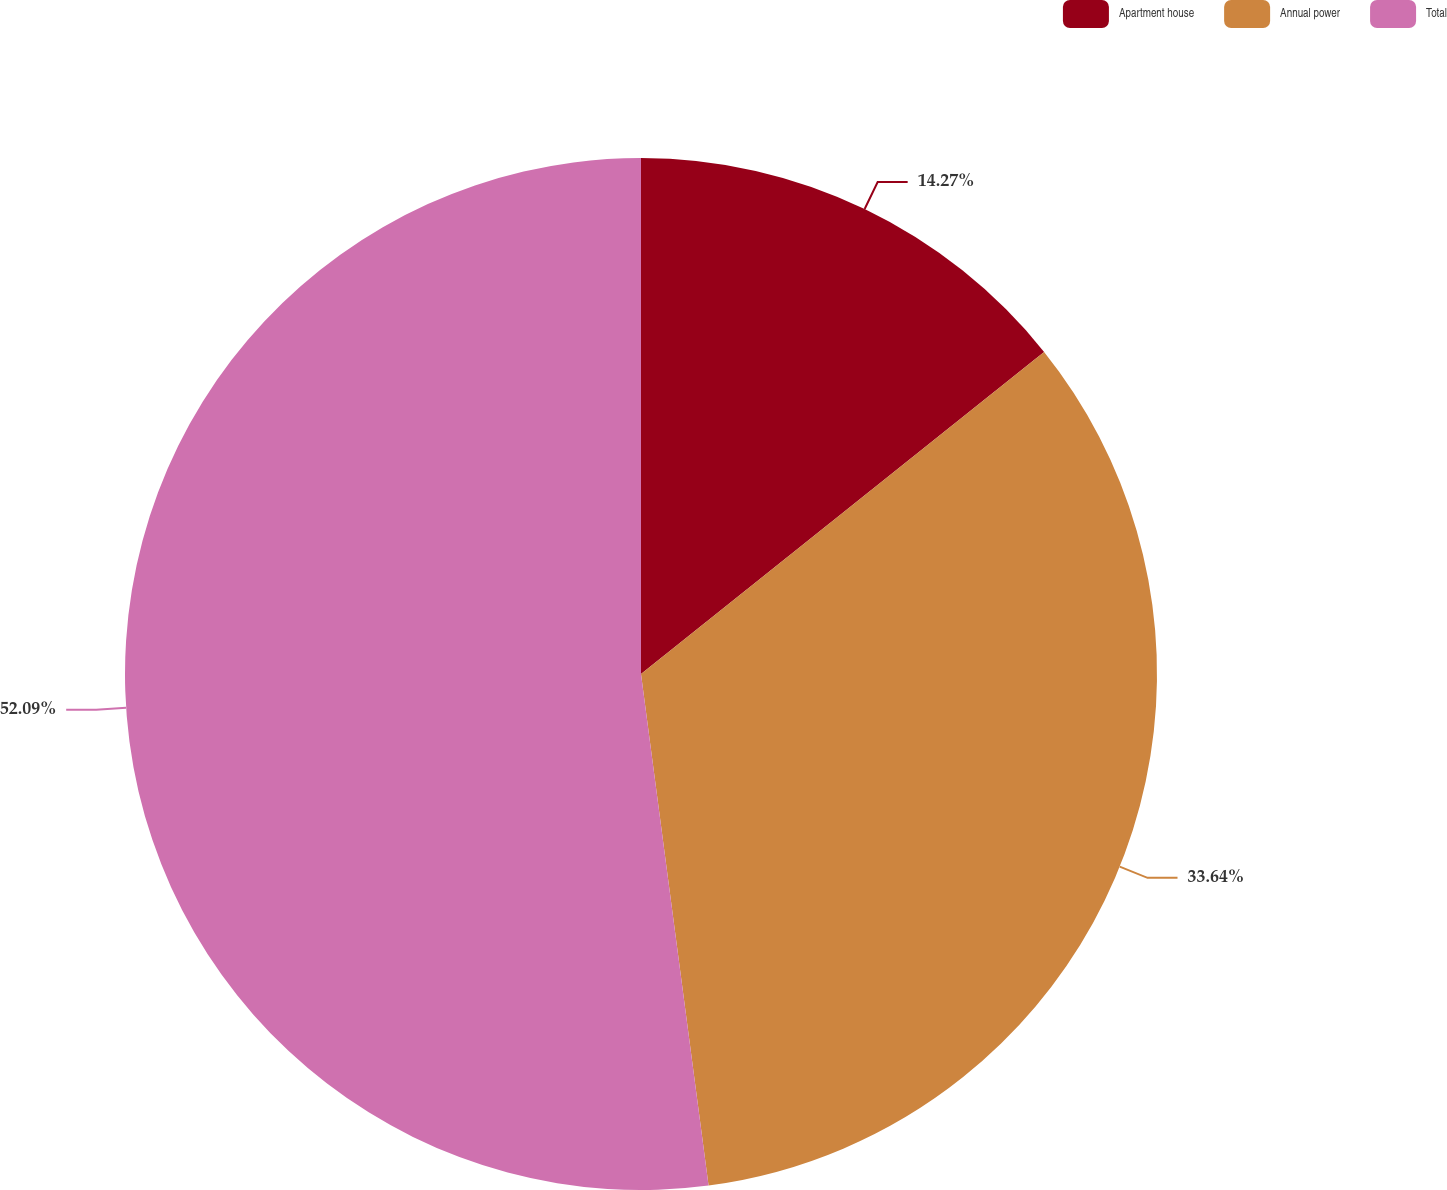Convert chart. <chart><loc_0><loc_0><loc_500><loc_500><pie_chart><fcel>Apartment house<fcel>Annual power<fcel>Total<nl><fcel>14.27%<fcel>33.64%<fcel>52.09%<nl></chart> 